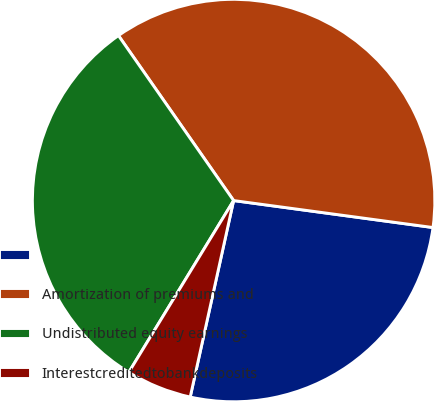Convert chart. <chart><loc_0><loc_0><loc_500><loc_500><pie_chart><ecel><fcel>Amortization of premiums and<fcel>Undistributed equity earnings<fcel>Interestcreditedtobankdeposits<nl><fcel>26.32%<fcel>36.84%<fcel>31.58%<fcel>5.26%<nl></chart> 